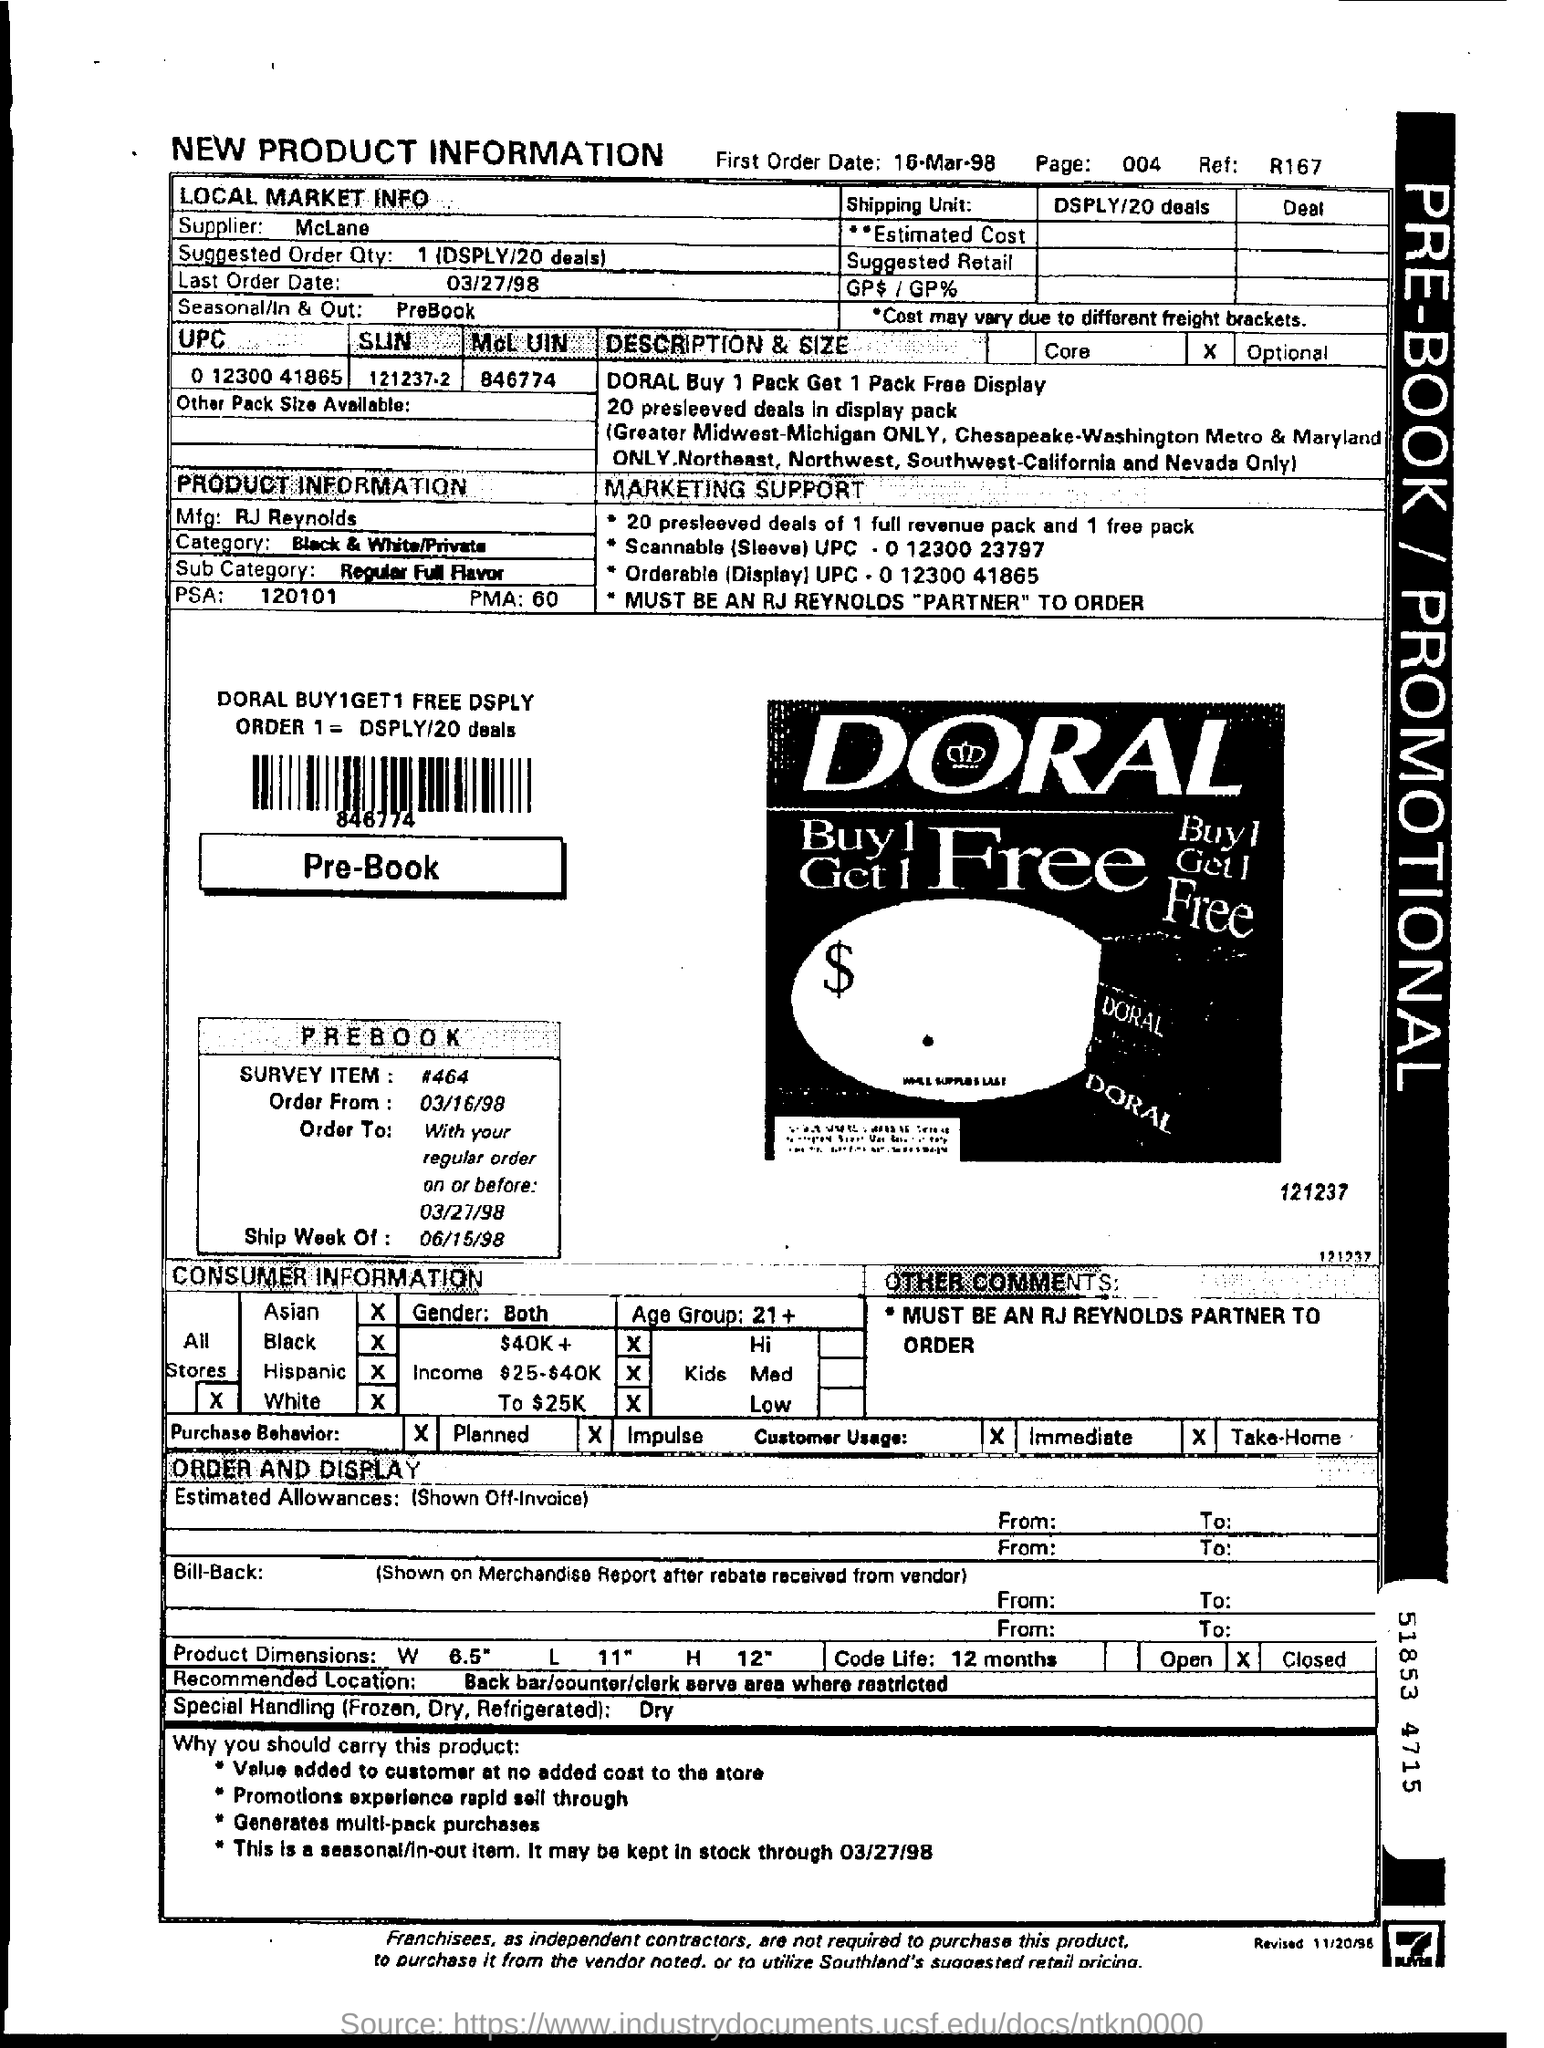What is the name of supplier?
Ensure brevity in your answer.  McLane. What is the suggested order quantity?
Keep it short and to the point. 1(DSPLY 20deals). What is the last order date?
Ensure brevity in your answer.  03/27/98. Who is the manufacturer of the product?
Provide a succinct answer. RJ Reynolds. To which category do the product belong?
Ensure brevity in your answer.  Black & White/Private. What is the psa no of the product?
Your answer should be very brief. 120101. What is the PMA no of the product?
Your answer should be compact. 60. What is the first order date?
Your answer should be compact. 16-Mar-98. 